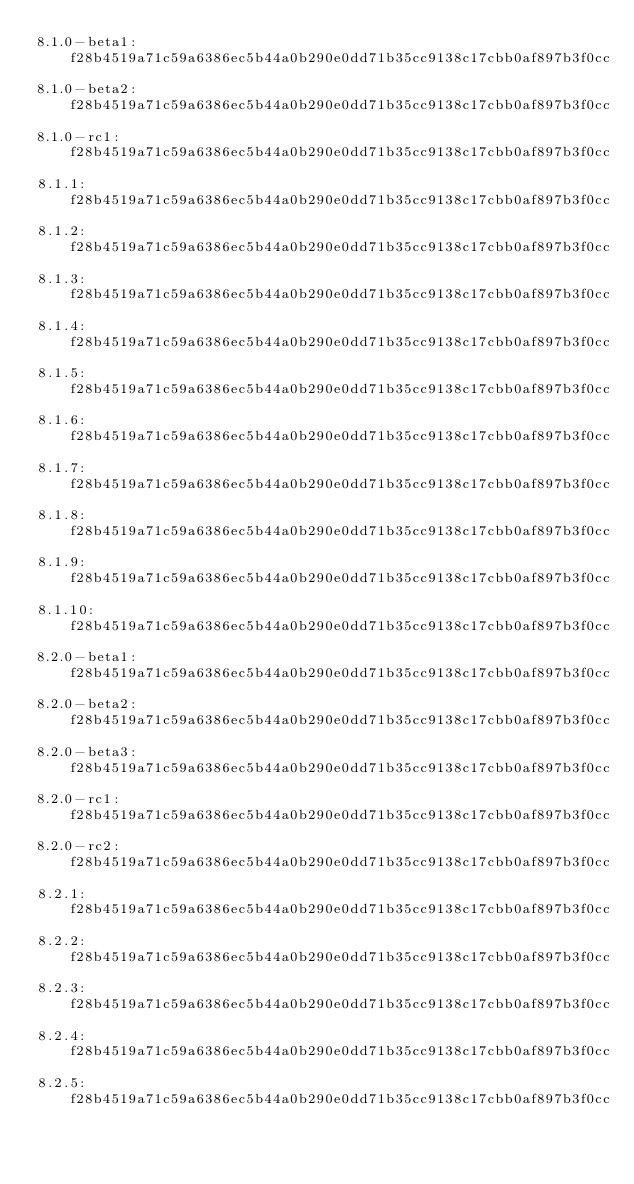<code> <loc_0><loc_0><loc_500><loc_500><_CSS_>8.1.0-beta1:f28b4519a71c59a6386ec5b44a0b290e0dd71b35cc9138c17cbb0af897b3f0cc
8.1.0-beta2:f28b4519a71c59a6386ec5b44a0b290e0dd71b35cc9138c17cbb0af897b3f0cc
8.1.0-rc1:f28b4519a71c59a6386ec5b44a0b290e0dd71b35cc9138c17cbb0af897b3f0cc
8.1.1:f28b4519a71c59a6386ec5b44a0b290e0dd71b35cc9138c17cbb0af897b3f0cc
8.1.2:f28b4519a71c59a6386ec5b44a0b290e0dd71b35cc9138c17cbb0af897b3f0cc
8.1.3:f28b4519a71c59a6386ec5b44a0b290e0dd71b35cc9138c17cbb0af897b3f0cc
8.1.4:f28b4519a71c59a6386ec5b44a0b290e0dd71b35cc9138c17cbb0af897b3f0cc
8.1.5:f28b4519a71c59a6386ec5b44a0b290e0dd71b35cc9138c17cbb0af897b3f0cc
8.1.6:f28b4519a71c59a6386ec5b44a0b290e0dd71b35cc9138c17cbb0af897b3f0cc
8.1.7:f28b4519a71c59a6386ec5b44a0b290e0dd71b35cc9138c17cbb0af897b3f0cc
8.1.8:f28b4519a71c59a6386ec5b44a0b290e0dd71b35cc9138c17cbb0af897b3f0cc
8.1.9:f28b4519a71c59a6386ec5b44a0b290e0dd71b35cc9138c17cbb0af897b3f0cc
8.1.10:f28b4519a71c59a6386ec5b44a0b290e0dd71b35cc9138c17cbb0af897b3f0cc
8.2.0-beta1:f28b4519a71c59a6386ec5b44a0b290e0dd71b35cc9138c17cbb0af897b3f0cc
8.2.0-beta2:f28b4519a71c59a6386ec5b44a0b290e0dd71b35cc9138c17cbb0af897b3f0cc
8.2.0-beta3:f28b4519a71c59a6386ec5b44a0b290e0dd71b35cc9138c17cbb0af897b3f0cc
8.2.0-rc1:f28b4519a71c59a6386ec5b44a0b290e0dd71b35cc9138c17cbb0af897b3f0cc
8.2.0-rc2:f28b4519a71c59a6386ec5b44a0b290e0dd71b35cc9138c17cbb0af897b3f0cc
8.2.1:f28b4519a71c59a6386ec5b44a0b290e0dd71b35cc9138c17cbb0af897b3f0cc
8.2.2:f28b4519a71c59a6386ec5b44a0b290e0dd71b35cc9138c17cbb0af897b3f0cc
8.2.3:f28b4519a71c59a6386ec5b44a0b290e0dd71b35cc9138c17cbb0af897b3f0cc
8.2.4:f28b4519a71c59a6386ec5b44a0b290e0dd71b35cc9138c17cbb0af897b3f0cc
8.2.5:f28b4519a71c59a6386ec5b44a0b290e0dd71b35cc9138c17cbb0af897b3f0cc</code> 